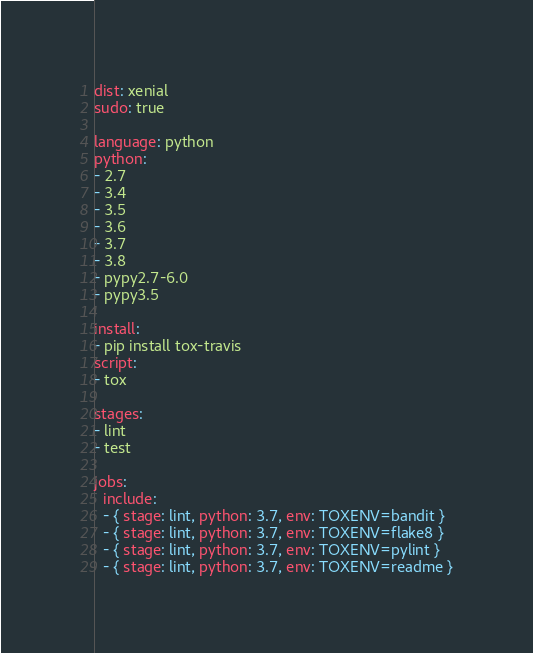Convert code to text. <code><loc_0><loc_0><loc_500><loc_500><_YAML_>dist: xenial
sudo: true

language: python
python:
- 2.7
- 3.4
- 3.5
- 3.6
- 3.7
- 3.8
- pypy2.7-6.0
- pypy3.5

install:
- pip install tox-travis
script:
- tox

stages:
- lint
- test

jobs:
  include:
  - { stage: lint, python: 3.7, env: TOXENV=bandit }
  - { stage: lint, python: 3.7, env: TOXENV=flake8 }
  - { stage: lint, python: 3.7, env: TOXENV=pylint }
  - { stage: lint, python: 3.7, env: TOXENV=readme }
</code> 